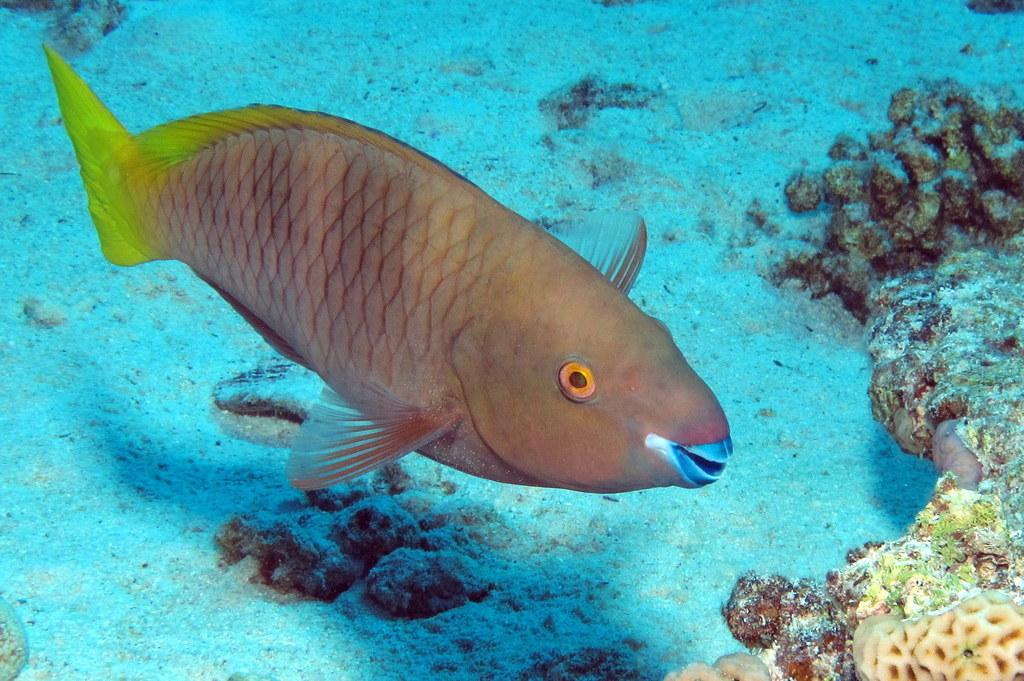What type of animal can be seen in the water in the image? There is a fish in the water in the image. How many oranges are being held by the robin in the image? There is no robin or oranges present in the image; it features a fish in the water. 